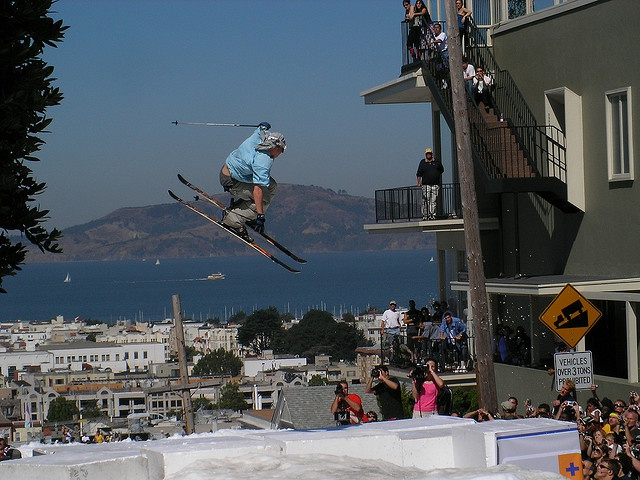Describe the objects in this image and their specific colors. I can see people in black, gray, and maroon tones, people in black, gray, and lightblue tones, skis in black, gray, darkblue, and maroon tones, people in black, maroon, and brown tones, and people in black, brown, maroon, and gray tones in this image. 